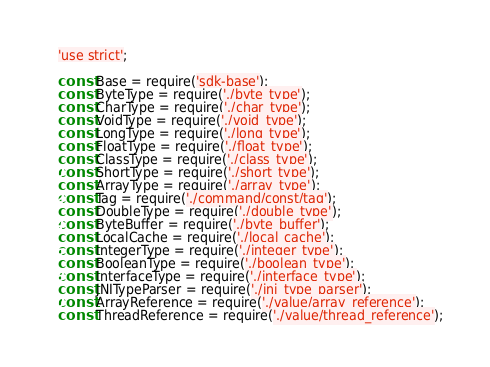Convert code to text. <code><loc_0><loc_0><loc_500><loc_500><_JavaScript_>'use strict';

const Base = require('sdk-base');
const ByteType = require('./byte_type');
const CharType = require('./char_type');
const VoidType = require('./void_type');
const LongType = require('./long_type');
const FloatType = require('./float_type');
const ClassType = require('./class_type');
const ShortType = require('./short_type');
const ArrayType = require('./array_type');
const Tag = require('./command/const/tag');
const DoubleType = require('./double_type');
const ByteBuffer = require('./byte_buffer');
const LocalCache = require('./local_cache');
const IntegerType = require('./integer_type');
const BooleanType = require('./boolean_type');
const InterfaceType = require('./interface_type');
const JNITypeParser = require('./jni_type_parser');
const ArrayReference = require('./value/array_reference');
const ThreadReference = require('./value/thread_reference');</code> 